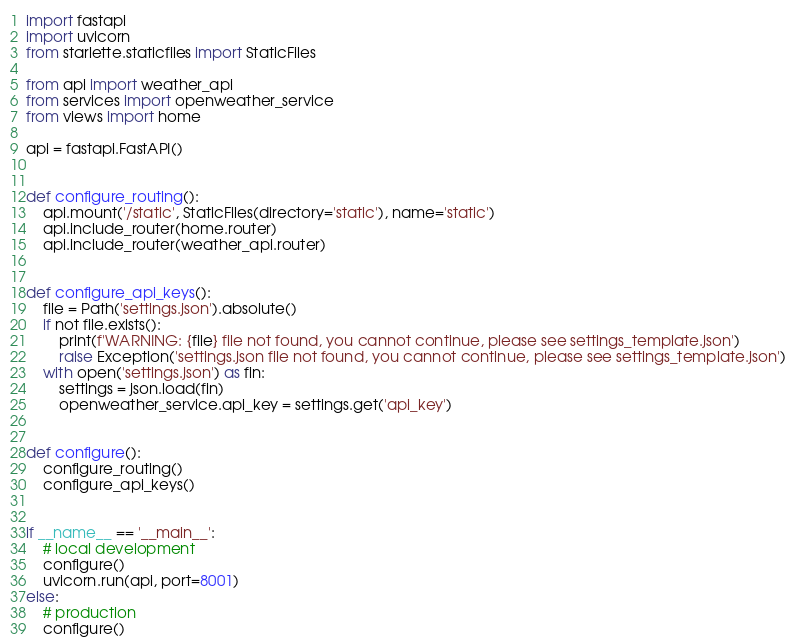Convert code to text. <code><loc_0><loc_0><loc_500><loc_500><_Python_>
import fastapi
import uvicorn
from starlette.staticfiles import StaticFiles

from api import weather_api
from services import openweather_service
from views import home

api = fastapi.FastAPI()


def configure_routing():
    api.mount('/static', StaticFiles(directory='static'), name='static')
    api.include_router(home.router)
    api.include_router(weather_api.router)


def configure_api_keys():
    file = Path('settings.json').absolute()
    if not file.exists():
        print(f'WARNING: {file} file not found, you cannot continue, please see settings_template.json')
        raise Exception('settings.json file not found, you cannot continue, please see settings_template.json')
    with open('settings.json') as fin:
        settings = json.load(fin)
        openweather_service.api_key = settings.get('api_key')


def configure():
    configure_routing()
    configure_api_keys()


if __name__ == '__main__':
    # local development
    configure()
    uvicorn.run(api, port=8001)
else:
    # production
    configure()</code> 